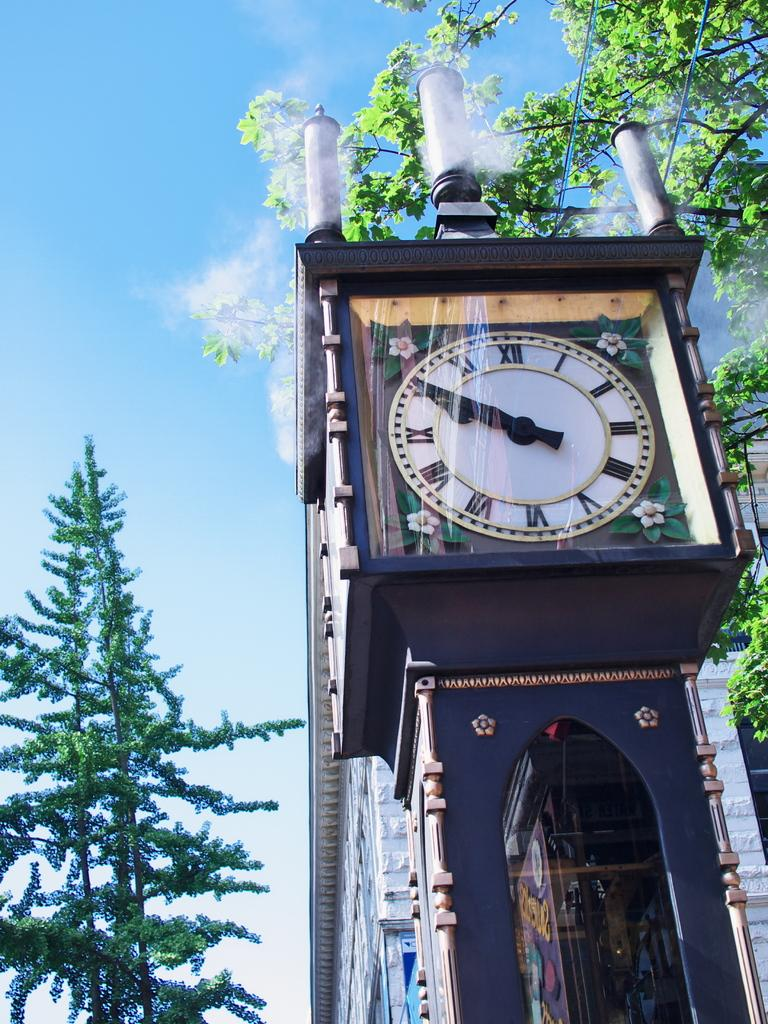<image>
Share a concise interpretation of the image provided. A clock has the numeral IX on the left side and III on the right side. 